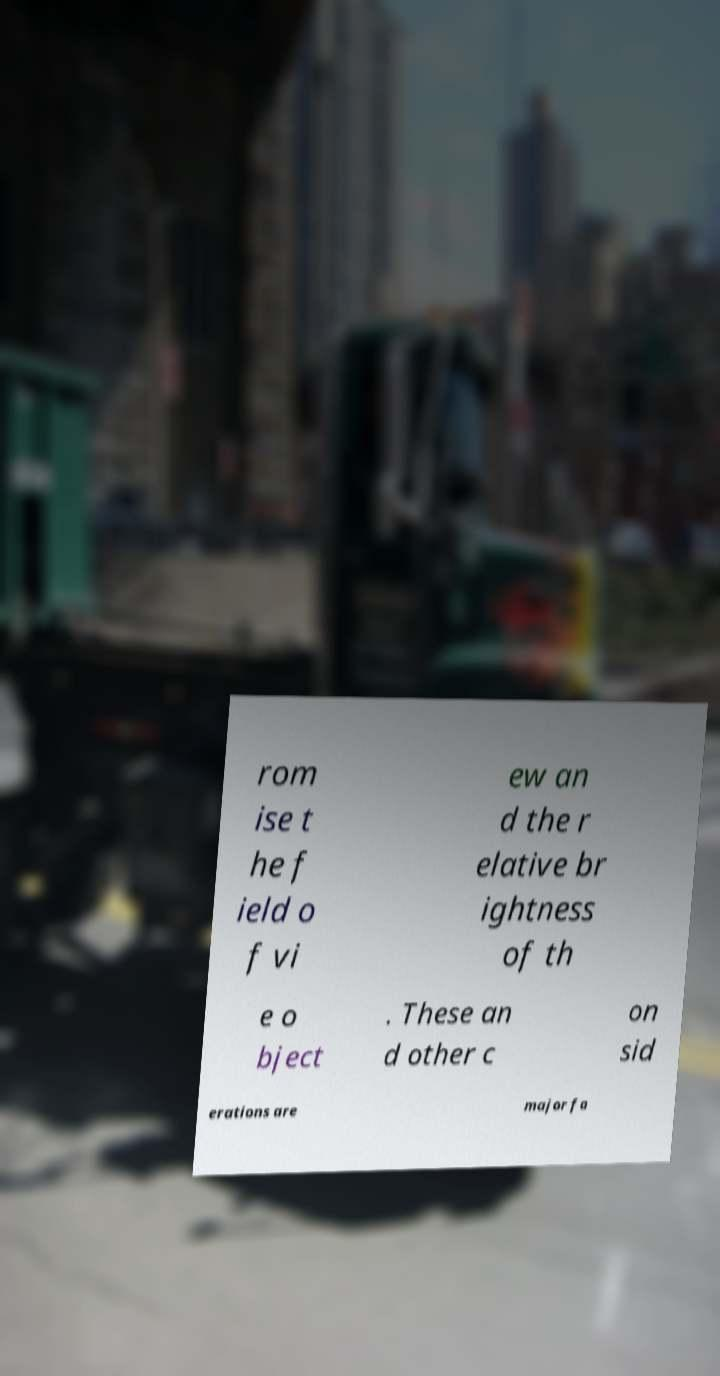I need the written content from this picture converted into text. Can you do that? rom ise t he f ield o f vi ew an d the r elative br ightness of th e o bject . These an d other c on sid erations are major fa 